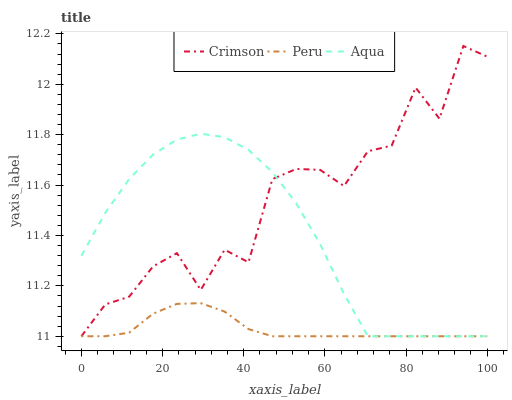Does Aqua have the minimum area under the curve?
Answer yes or no. No. Does Aqua have the maximum area under the curve?
Answer yes or no. No. Is Aqua the smoothest?
Answer yes or no. No. Is Aqua the roughest?
Answer yes or no. No. Does Aqua have the highest value?
Answer yes or no. No. 